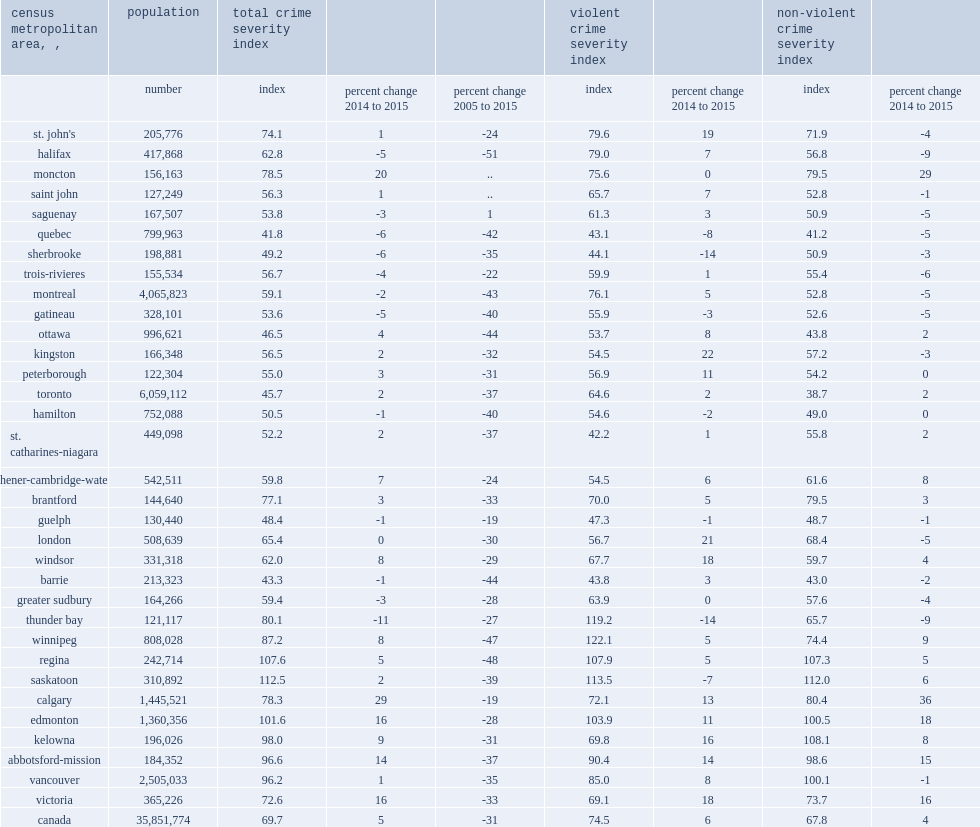Calgary recorded the largest increase in csi,what is the percentage of it? driven by increased incidents of breaking and entering, theft of $5,000 or under, and motor vehicle theft in 2015. 29.0. What is the percentage of increases in the csi were also recorded in moncton in 2015? 20.0. What is the percentage of increases in the csi were also recorded in victoria in 2015? 16.0. What is the percentage of increases in the csi were also recorded in edmonton in 2015? 16.0. What is the percentage of increases in the csi were also recorded in abbotsford-mission in 2015? 14.0. What is the cmas with the largest declines in csi of thunder bay in 2015? 11. What is the cmas with the largest declines in csi of quebec in 2015? 6. What is the cmas with the largest declines in csi of sherbrooke in 2015? 6. What is the percentage of toronto which together account for over one third of canada's population, reported ten-year decreases? 37. What is the largest declines between 2005 and 2015 reported by halifax? 51. The only cma to report an increase compared to 2005 was saguenay, what the percentage recorded a relatively low csi in 2005 compared to the year before and after? 1.0. What is the largest increases in the non-violent csi were in calgary?, all mainly due to increased levels of breaking and entering and theft of $5,000 or under. 36.0. In contrast, what is the notable declines in the non-violent csi were reported in halifax in 2015? 9. 